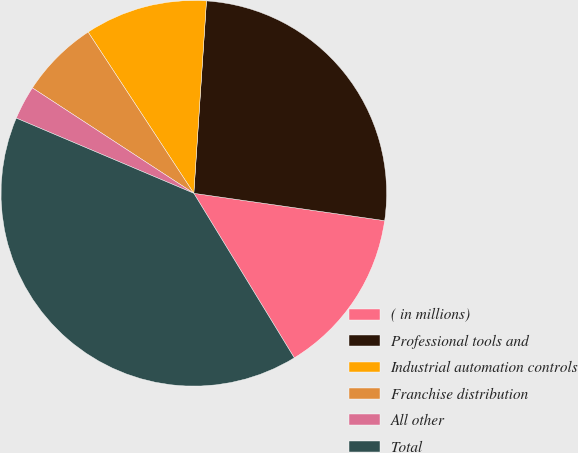<chart> <loc_0><loc_0><loc_500><loc_500><pie_chart><fcel>( in millions)<fcel>Professional tools and<fcel>Industrial automation controls<fcel>Franchise distribution<fcel>All other<fcel>Total<nl><fcel>14.01%<fcel>26.22%<fcel>10.28%<fcel>6.56%<fcel>2.83%<fcel>40.1%<nl></chart> 